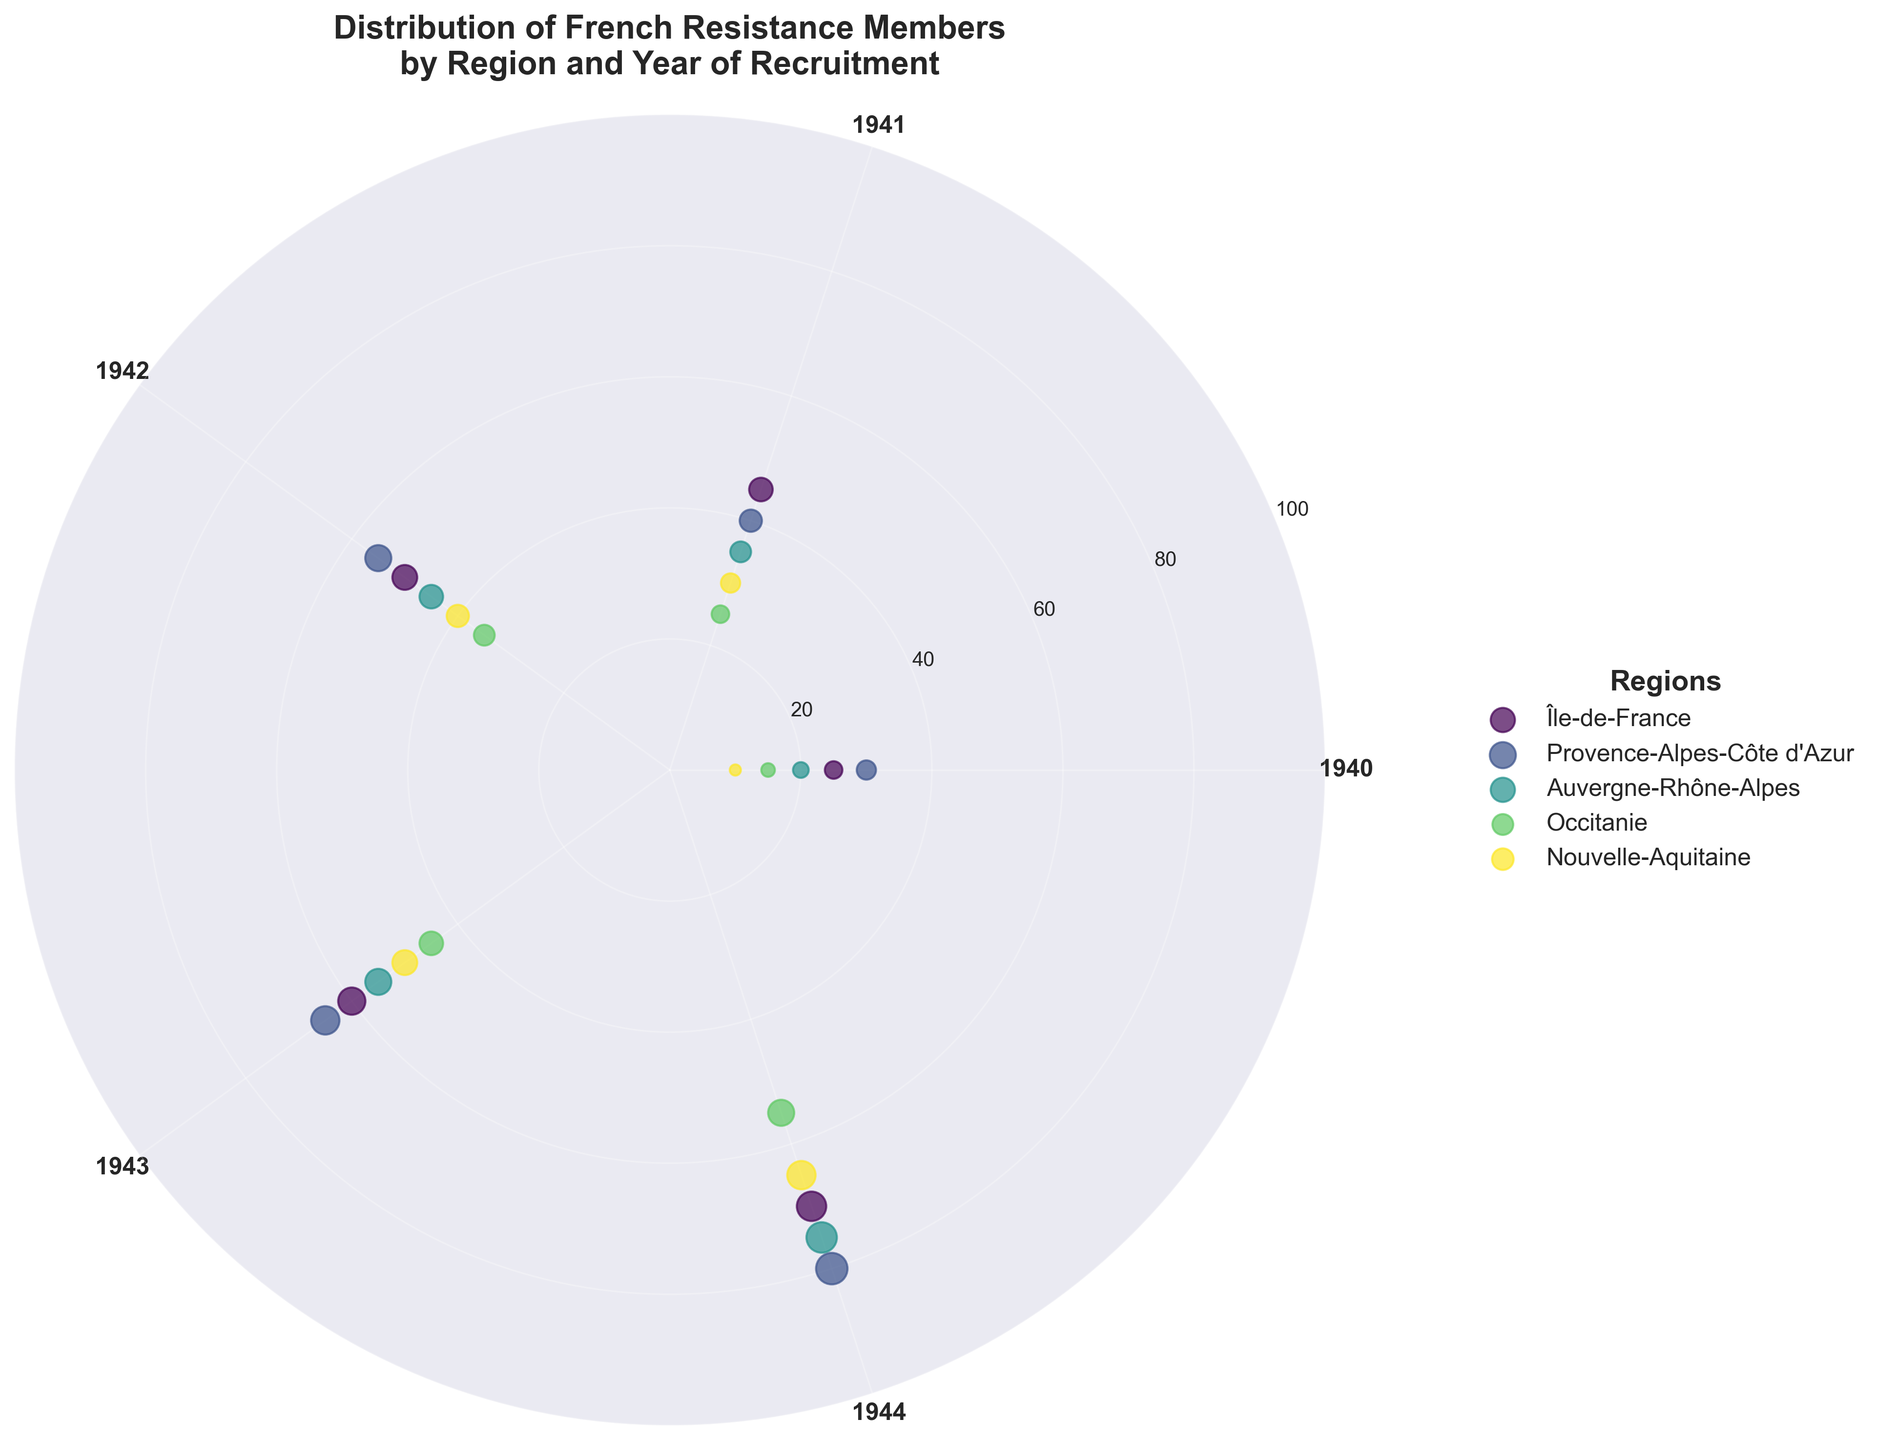What is the title of the figure? Look at the top of the figure to identify the main title.
Answer: Distribution of French Resistance Members by Region and Year of Recruitment What color does the region Île-de-France have in the scatter plot? Identify the color in the scatter plot legend corresponding to Île-de-France.
Answer: Dark purple In which year does Auvergne-Rhône-Alpes have the most members? Locate the spikes for Auvergne-Rhône-Alpes and determine which year it reaches its highest value.
Answer: 1944 How does the number of members in Provence-Alpes-Côte d'Azur change from 1940 to 1944? Trace the points for Provence-Alpes-Côte d'Azur from 1940 to 1944 and observe the trend in the member count.
Answer: Increases Compare the number of members in Nouvelle-Aquitaine in 1941 and Occitanie in 1944. Which region has more members? Locate the scatter points for Nouvelle-Aquitaine in 1941 and Occitanie in 1944, then compare the values.
Answer: Occitanie Which region has the smallest increase in members from 1940 to 1944? For each region, calculate the increase from 1940 to 1944 and determine which region has the smallest difference.
Answer: Occitanie What general trend is observable in the number of members from 1940 to 1944 across all regions? Analyze the overall direction of change in the member counts as years progress from 1940 to 1944.
Answer: Increasing trend On which years do all regions have data points? Identify the years shown on the polar axis and confirm that each year has data points for all regions.
Answer: 1940, 1941, 1942, 1943, 1944 What is the total number of members from Île-de-France across all years shown in the figure? Sum the number of members in Île-de-France for each year displayed.
Answer: (25 + 45 + 50 + 60 + 70) = 250 Which two regions have the closest number of members in a particular year, and what is that year? Compare the scatter points for different regions within each year, identifying the closest values.
Answer: Île-de-France and Auvergne-Rhône-Alpes in 1942 